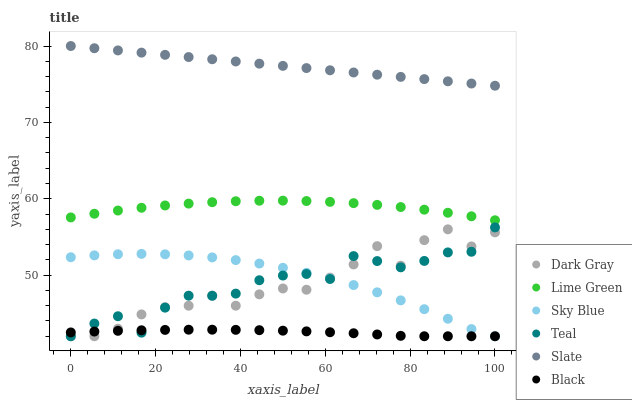Does Black have the minimum area under the curve?
Answer yes or no. Yes. Does Slate have the maximum area under the curve?
Answer yes or no. Yes. Does Dark Gray have the minimum area under the curve?
Answer yes or no. No. Does Dark Gray have the maximum area under the curve?
Answer yes or no. No. Is Slate the smoothest?
Answer yes or no. Yes. Is Dark Gray the roughest?
Answer yes or no. Yes. Is Black the smoothest?
Answer yes or no. No. Is Black the roughest?
Answer yes or no. No. Does Dark Gray have the lowest value?
Answer yes or no. Yes. Does Lime Green have the lowest value?
Answer yes or no. No. Does Slate have the highest value?
Answer yes or no. Yes. Does Dark Gray have the highest value?
Answer yes or no. No. Is Sky Blue less than Lime Green?
Answer yes or no. Yes. Is Slate greater than Sky Blue?
Answer yes or no. Yes. Does Dark Gray intersect Black?
Answer yes or no. Yes. Is Dark Gray less than Black?
Answer yes or no. No. Is Dark Gray greater than Black?
Answer yes or no. No. Does Sky Blue intersect Lime Green?
Answer yes or no. No. 